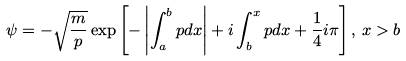Convert formula to latex. <formula><loc_0><loc_0><loc_500><loc_500>\psi = - \sqrt { \frac { m } { p } } \exp \left [ - \left | \int ^ { b } _ { a } p d x \right | + i \int ^ { x } _ { b } p d x + \frac { 1 } { 4 } i \pi \right ] , \, x > b</formula> 